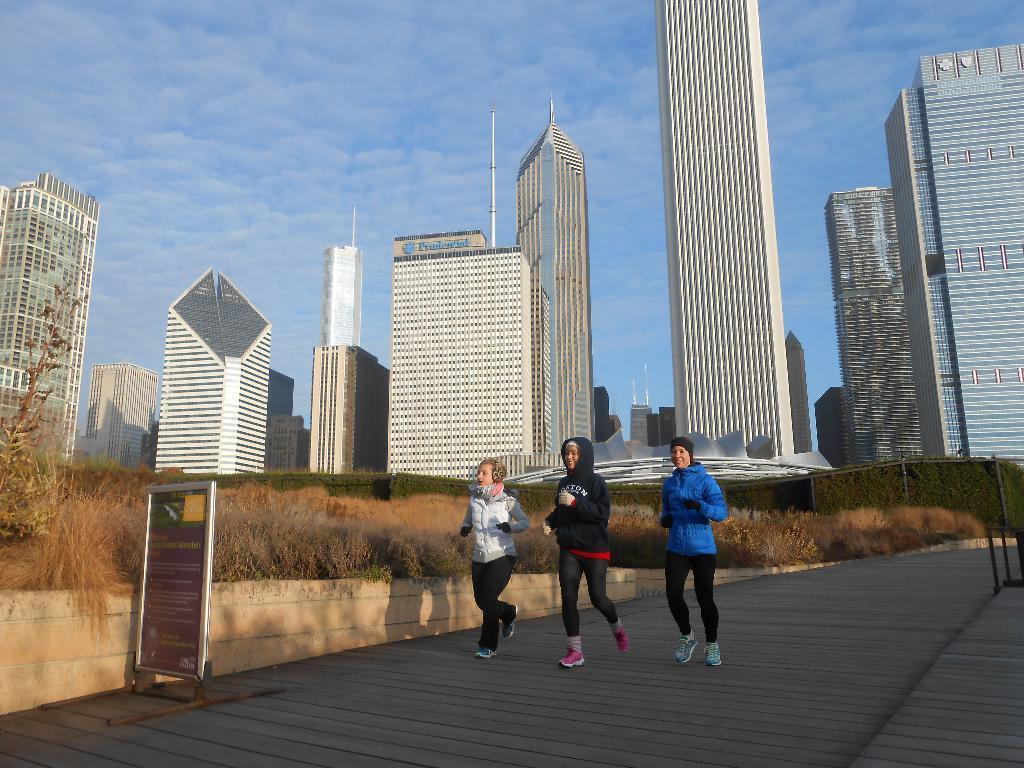How would you summarize this image in a sentence or two? In this image in the center there are persons running and there are dry plants and there is a board with some text written on it. In the background there are buildings and the sky is cloudy. 